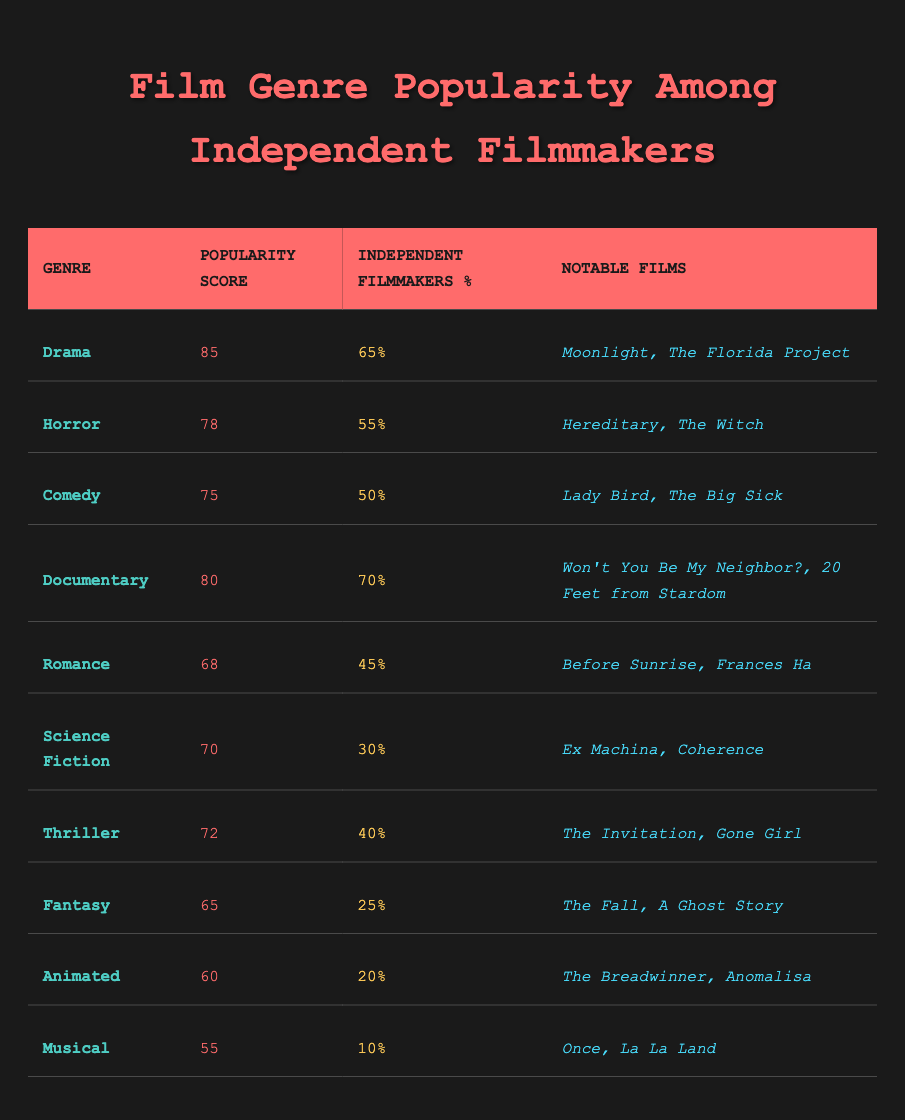What is the popularity score of the Comedy genre? The table clearly lists the Comedy genre under the "Genre" column, and its corresponding "Popularity Score" is presented in the same row. It shows a score of 75.
Answer: 75 Which film genre has the highest percentage of independent filmmakers? By reviewing the table, we see the "Independent Filmmakers %" column, where the Documentary genre has the highest percentage listed at 70%.
Answer: Documentary What are the notable films in the Horror genre? The Horror genre row in the table shows the notable films associated with it, which are "Hereditary" and "The Witch."
Answer: Hereditary, The Witch Is the Romance genre more popular than the Thriller genre? Based on the "Popularity Score" column, the Romance genre has a score of 68, while the Thriller genre's score is 72. Since 68 is less than 72, Romance is not more popular.
Answer: No What is the average popularity score of the listed genres? To find the average, we sum all the popularity scores: 85 + 78 + 75 + 80 + 68 + 70 + 72 + 65 + 60 + 55 =  78.5, then divide by the number of genres (10): 785/10 = 78.5. Hence, the average popularity score is 78.5.
Answer: 78.5 Does the Fantasy genre have a higher score than both Animated and Musical genres combined? The Fantasy genre score is 65, while the Animated score is 60 and the Musical score is 55. Adding the scores of Animated and Musical gives 60 + 55 = 115. Since 65 is less than 115, the Fantasy genre does not exceed the combined score.
Answer: No Which genre has the lowest popularity score, and what is its score? By scanning the table for the lowest value under the "Popularity Score" column, we identify the Musical genre with a score of 55.
Answer: Musical, 55 How many genres have a popularity score below 70? We can examine the "Popularity Score" column and count the number of genres with scores lower than 70. The genres are Romance (68), Science Fiction (70), Fantasy (65), Animated (60), and Musical (55), which totals to four genres.
Answer: 4 